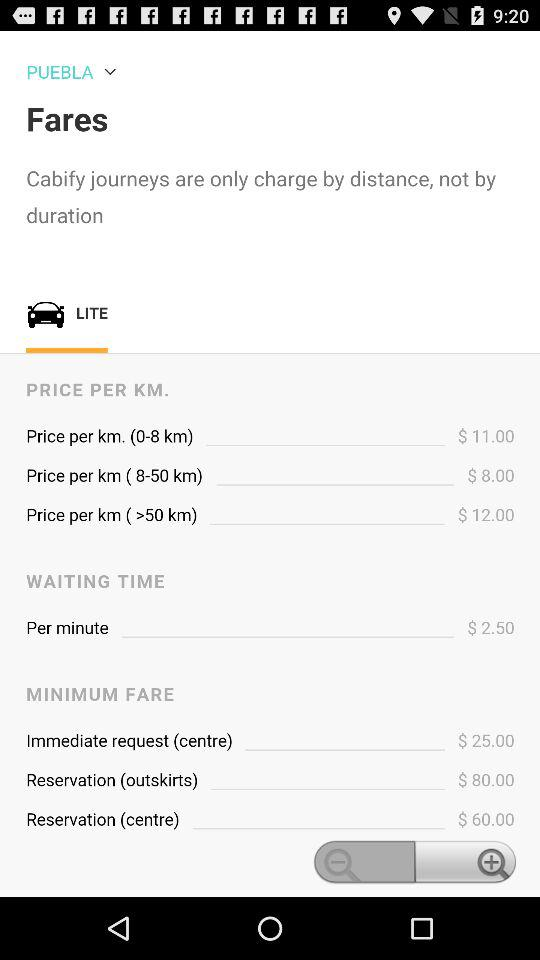What is the price per minute for the waiting time? The price for the waiting time is $2.50 per minute. 